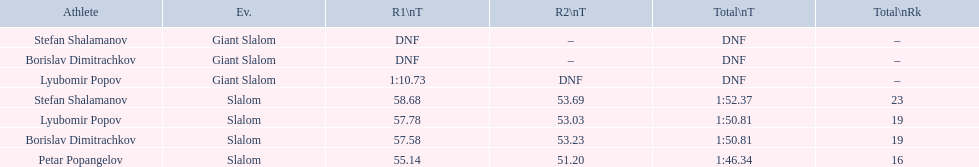How many athletes are there total? 4. 